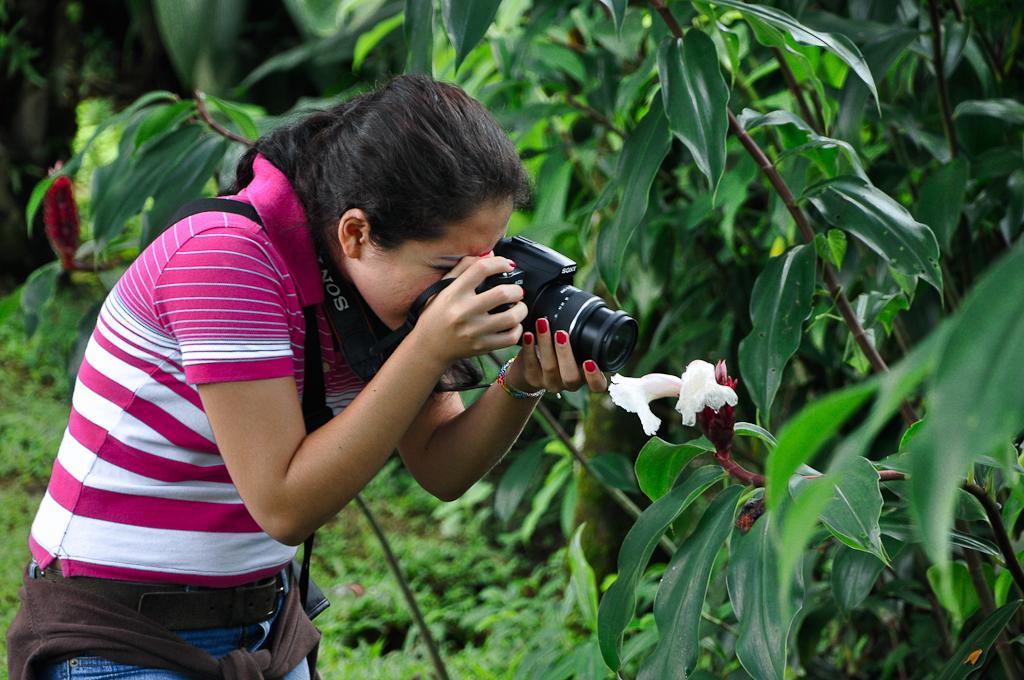Can you describe this image briefly? This woman is holding a camera and taking a snap of this flower. This is a plant. 